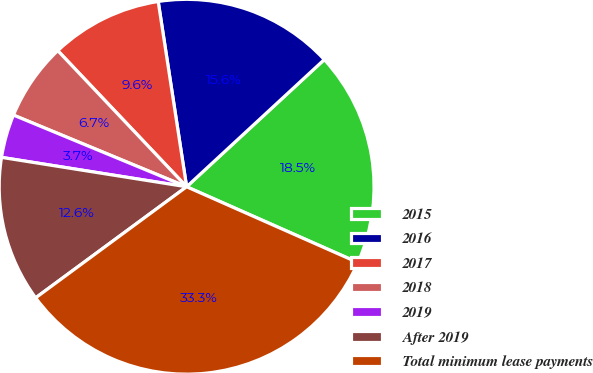Convert chart to OTSL. <chart><loc_0><loc_0><loc_500><loc_500><pie_chart><fcel>2015<fcel>2016<fcel>2017<fcel>2018<fcel>2019<fcel>After 2019<fcel>Total minimum lease payments<nl><fcel>18.5%<fcel>15.55%<fcel>9.64%<fcel>6.69%<fcel>3.74%<fcel>12.6%<fcel>33.27%<nl></chart> 